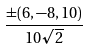Convert formula to latex. <formula><loc_0><loc_0><loc_500><loc_500>\frac { \pm ( 6 , - 8 , 1 0 ) } { 1 0 \sqrt { 2 } }</formula> 